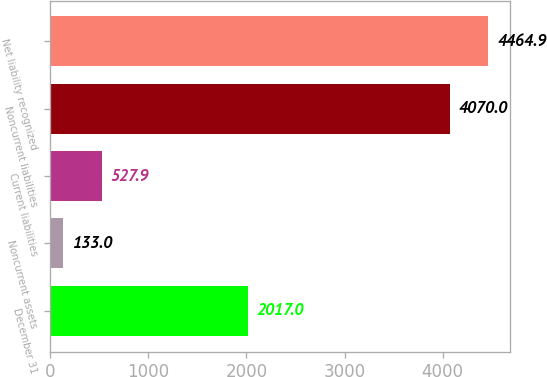Convert chart. <chart><loc_0><loc_0><loc_500><loc_500><bar_chart><fcel>December 31<fcel>Noncurrent assets<fcel>Current liabilities<fcel>Noncurrent liabilities<fcel>Net liability recognized<nl><fcel>2017<fcel>133<fcel>527.9<fcel>4070<fcel>4464.9<nl></chart> 